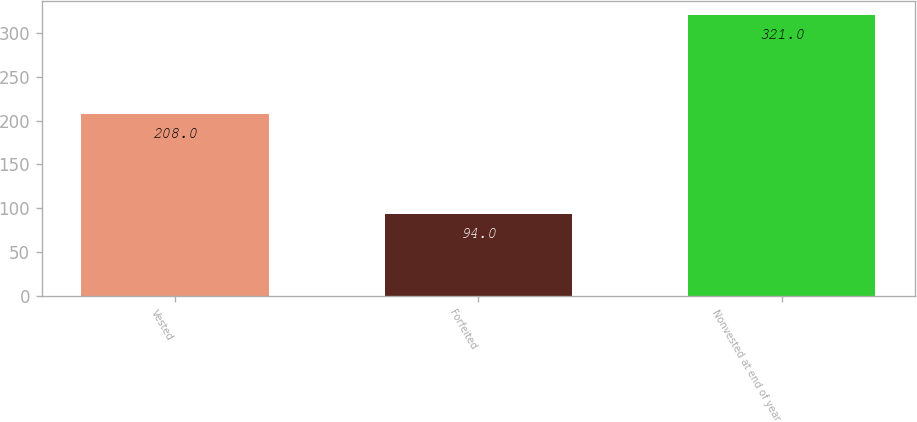Convert chart to OTSL. <chart><loc_0><loc_0><loc_500><loc_500><bar_chart><fcel>Vested<fcel>Forfeited<fcel>Nonvested at end of year<nl><fcel>208<fcel>94<fcel>321<nl></chart> 